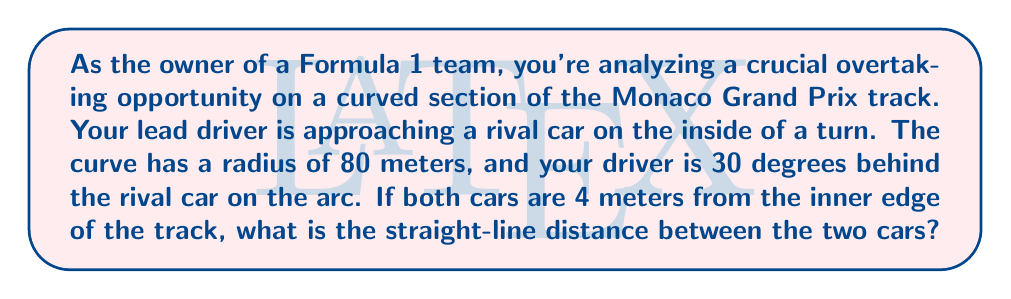Teach me how to tackle this problem. Let's approach this step-by-step:

1) First, we need to visualize the situation. The cars are on a circular arc, separated by 30 degrees.

[asy]
import geometry;

pair O=(0,0);
draw(circle(O,80));
pair A=80*dir(30);
pair B=80*dir(0);
draw(O--A--B--cycle,dashed);
draw(A--B,red);
label("O",O,SW);
label("A",A,NE);
label("B",B,E);
label("80m",O--B,S);
label("80m",O--A,NW);
label("30°",O,NE);
dot("Car 1",B,E);
dot("Car 2",A,NE);
[/asy]

2) We can treat this as an isosceles triangle, where two sides are radii of the circle (80m each), and the third side is the distance we're looking for.

3) We can use the law of cosines to find the length of the third side. The law of cosines states:

   $$c^2 = a^2 + b^2 - 2ab \cos(C)$$

   Where $c$ is the side we're looking for, $a$ and $b$ are the radii, and $C$ is the angle between them.

4) Plugging in our values:

   $$d^2 = 80^2 + 80^2 - 2(80)(80) \cos(30°)$$

5) Simplify:

   $$d^2 = 6400 + 6400 - 12800 \cos(30°)$$
   $$d^2 = 12800 - 12800 \cos(30°)$$

6) $\cos(30°) = \frac{\sqrt{3}}{2} \approx 0.866$

7) Substituting:

   $$d^2 = 12800 - 12800(0.866)$$
   $$d^2 = 12800 - 11084.8$$
   $$d^2 = 1715.2$$

8) Taking the square root:

   $$d = \sqrt{1715.2} \approx 41.42$$

Therefore, the straight-line distance between the two cars is approximately 41.42 meters.
Answer: The straight-line distance between the two cars is approximately 41.42 meters. 